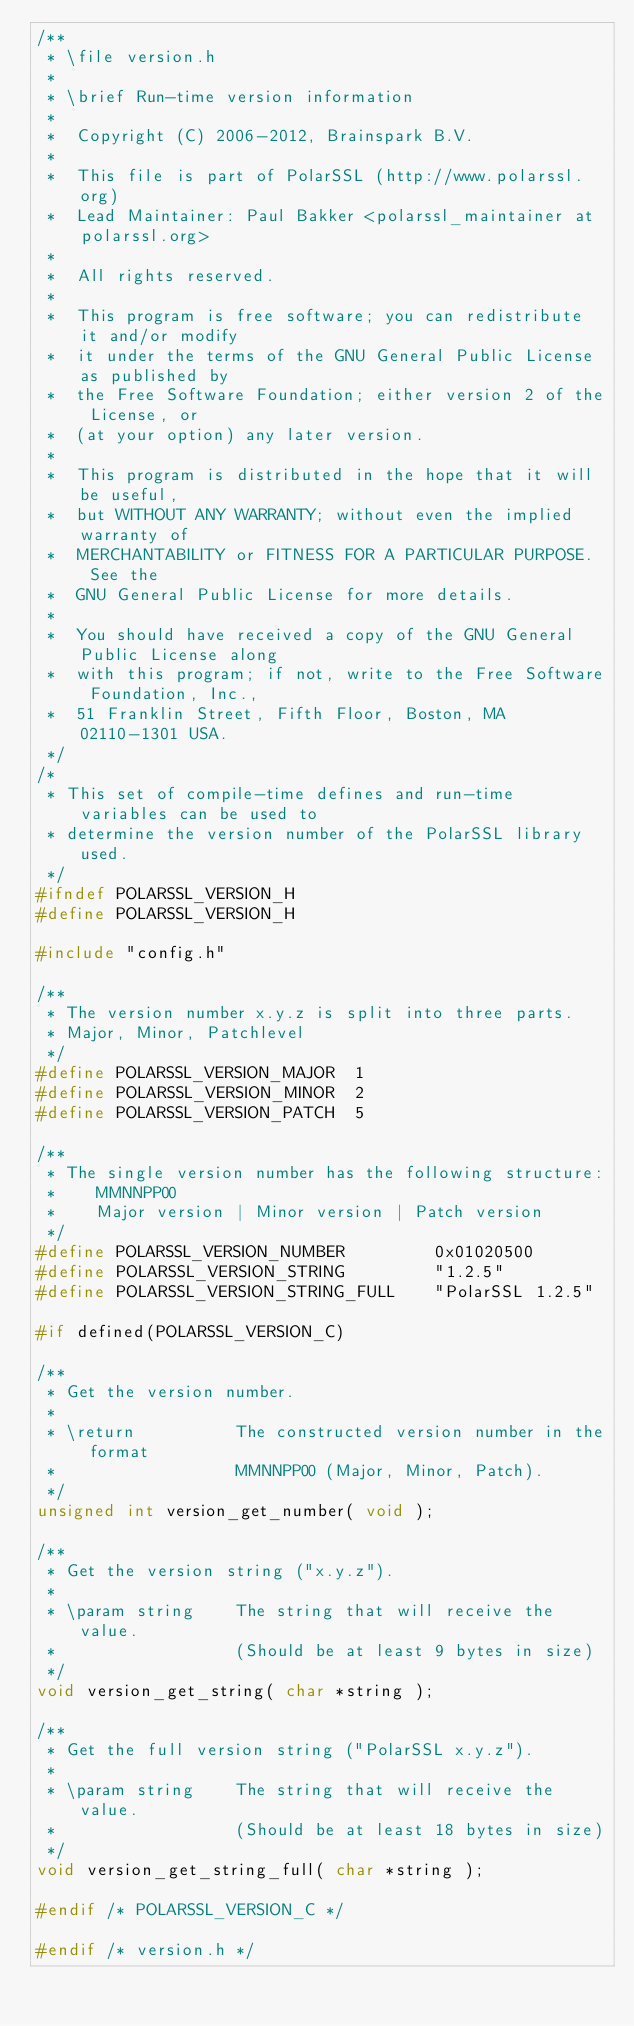Convert code to text. <code><loc_0><loc_0><loc_500><loc_500><_C_>/**
 * \file version.h
 *
 * \brief Run-time version information
 *
 *  Copyright (C) 2006-2012, Brainspark B.V.
 *
 *  This file is part of PolarSSL (http://www.polarssl.org)
 *  Lead Maintainer: Paul Bakker <polarssl_maintainer at polarssl.org>
 *
 *  All rights reserved.
 *
 *  This program is free software; you can redistribute it and/or modify
 *  it under the terms of the GNU General Public License as published by
 *  the Free Software Foundation; either version 2 of the License, or
 *  (at your option) any later version.
 *
 *  This program is distributed in the hope that it will be useful,
 *  but WITHOUT ANY WARRANTY; without even the implied warranty of
 *  MERCHANTABILITY or FITNESS FOR A PARTICULAR PURPOSE.  See the
 *  GNU General Public License for more details.
 *
 *  You should have received a copy of the GNU General Public License along
 *  with this program; if not, write to the Free Software Foundation, Inc.,
 *  51 Franklin Street, Fifth Floor, Boston, MA 02110-1301 USA.
 */
/*
 * This set of compile-time defines and run-time variables can be used to
 * determine the version number of the PolarSSL library used.
 */
#ifndef POLARSSL_VERSION_H
#define POLARSSL_VERSION_H

#include "config.h"

/**
 * The version number x.y.z is split into three parts.
 * Major, Minor, Patchlevel
 */
#define POLARSSL_VERSION_MAJOR  1
#define POLARSSL_VERSION_MINOR  2
#define POLARSSL_VERSION_PATCH  5

/**
 * The single version number has the following structure:
 *    MMNNPP00
 *    Major version | Minor version | Patch version
 */
#define POLARSSL_VERSION_NUMBER         0x01020500
#define POLARSSL_VERSION_STRING         "1.2.5"
#define POLARSSL_VERSION_STRING_FULL    "PolarSSL 1.2.5"

#if defined(POLARSSL_VERSION_C)

/**
 * Get the version number.
 *
 * \return          The constructed version number in the format
 *                  MMNNPP00 (Major, Minor, Patch).
 */
unsigned int version_get_number( void );

/**
 * Get the version string ("x.y.z").
 *
 * \param string    The string that will receive the value.
 *                  (Should be at least 9 bytes in size)
 */
void version_get_string( char *string );

/**
 * Get the full version string ("PolarSSL x.y.z").
 *
 * \param string    The string that will receive the value.
 *                  (Should be at least 18 bytes in size)
 */
void version_get_string_full( char *string );

#endif /* POLARSSL_VERSION_C */

#endif /* version.h */
</code> 